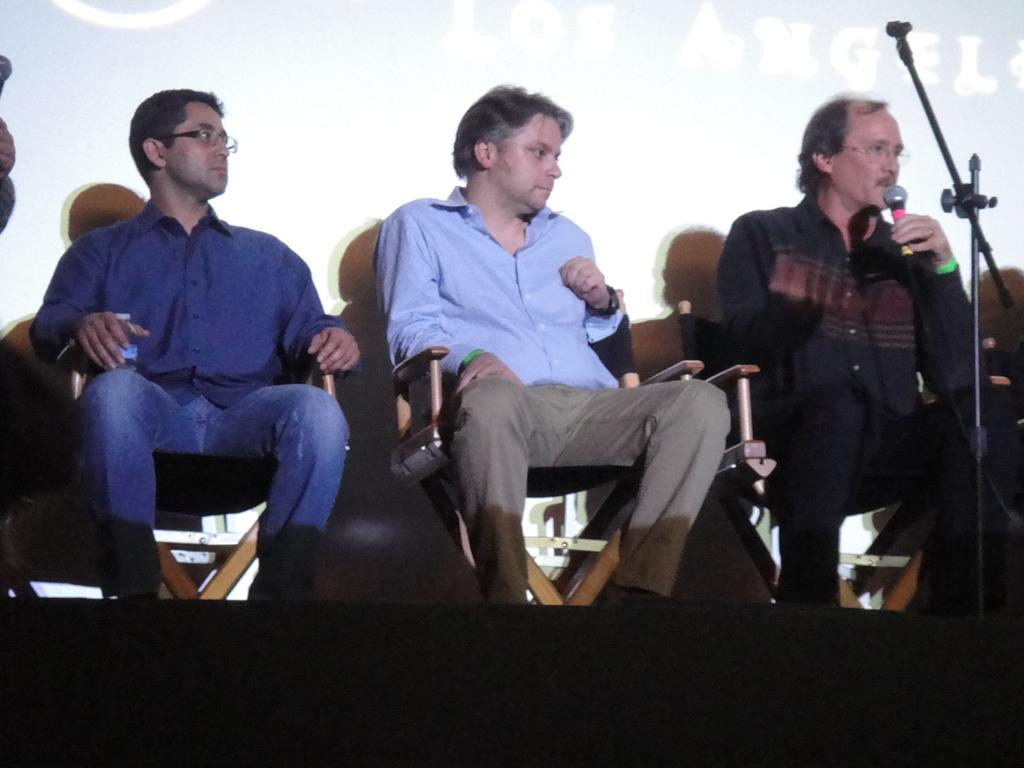How many people are in the image? There are three people in the image. What are the people doing in the image? The people are sitting on chairs. What colors are the shirts of the people wearing in the image? Two of the people are wearing blue shirts, and one is wearing a black shirt. Who is holding a microphone in the image? One person is holding a microphone. What can be seen in front of the people in the image? There is a mic stand in front of the people. Can you see any windows or markets in the image? No, there are no windows or markets visible in the image. Is there a fan present in the image? No, there is no fan present in the image. 